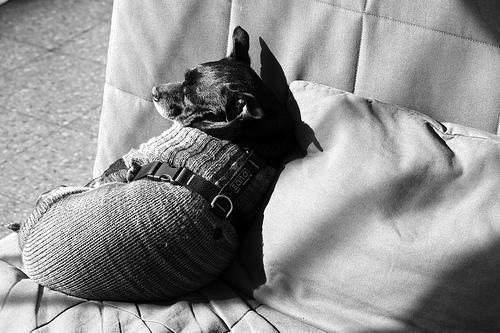How many human hands are petting the dog in the picture?
Give a very brief answer. 0. 